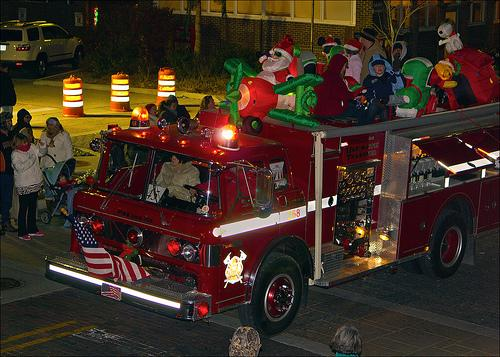Provide a brief description of the major subjects in the photograph and their actions. Decorated fire truck with Christmas inflatables, American flag; spectators and reflective barrels around. Outline the primary objects in the image and the events occurring. A festively adorned red fire truck, inclusive of an American flag and inflatables, is traversing the scene while people watch from the sidelines. Briefly describe the main subjects in the image and what is happening. Decorated American fire truck with Christmas inflatables is driving along while bystanders stand and watch. Delineate the chief components within the image and what's transpiring. A fire truck embellished with an American flag and assorted Christmas inflatables is driving along the street as viewers stand nearby. Explain the key components in the image and the activity taking place. A festively decorated red fire truck, featuring an American flag and multiple Christmas inflatables, is seen moving along as onlookers gather around. Describe the predominant features in the photograph and their actions. A red fire truck displaying an American flag and various inflatables is driving down a road as onlookers gather to watch. Write a concise summary of the main elements in the picture and their actions. Red fire truck with flag, Christmas inflatables on top; spectators and three construction barrels nearby. Narrate the most noticeable items in the image along with their actions. An adorned red fire truck, with an American flag and numerous Christmas-themed inflatables, is passing by as people watch from the side of the street. Identify the primary elements in the picture and explain what they are doing. A red fire engine, carrying an American flag and holiday inflatables, is moving through the scene as people observe from the sidewalk. Mention the primary focus of the image and what is happening. A red fire truck with American flag and various inflatable Christmas characters, is decorated and driving along while people watch from the sidelines. 